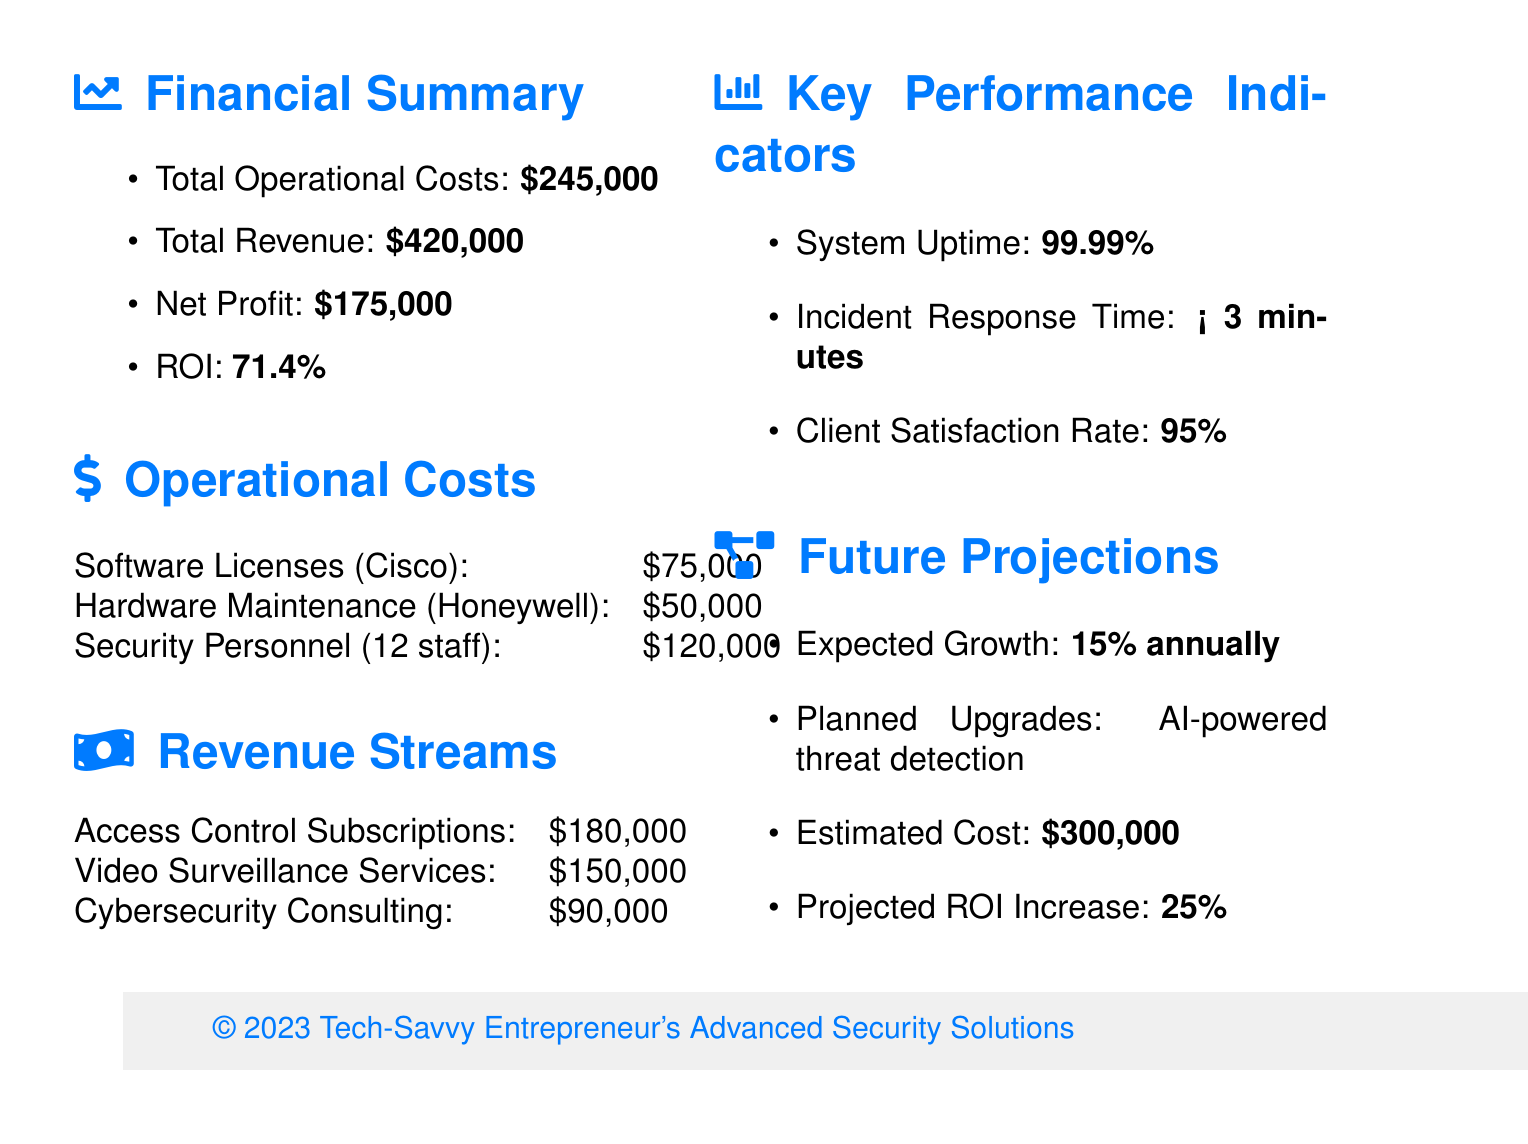what are the total operational costs? The total operational costs are explicitly mentioned in the financial summary section of the document as $245,000.
Answer: $245,000 what is the net profit? The net profit is calculated in the financial summary section of the document and is stated as $175,000.
Answer: $175,000 how much is spent on software licenses? The quarterly expense for software licenses from Cisco Systems is provided in the operational costs section of the document as $75,000.
Answer: $75,000 what is the quarterly revenue from video surveillance services? The quarterly revenue from video surveillance services is detailed in the revenue streams section and is listed as $150,000.
Answer: $150,000 what is the ROI percentage? The ROI percentage is calculated and reported in the financial summary section of the document as 71.4%.
Answer: 71.4% how many staff are employed as security personnel? The number of security personnel is indicated in the operational costs section of the document as 12 staff members.
Answer: 12 staff what is the expected annual growth rate? The expected annual growth rate is stated in the future projections section of the document as 15%.
Answer: 15% what is the projected increase in ROI after planned upgrades? The document mentions that the projected increase in ROI from planned upgrades is 25%.
Answer: 25% how satisfied are clients according to the satisfaction rate? The client satisfaction rate is presented in the key performance indicators section, where it states 95%.
Answer: 95% 